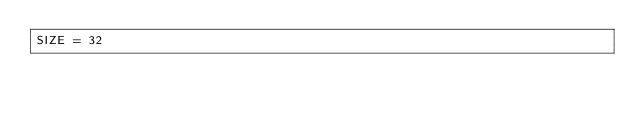<code> <loc_0><loc_0><loc_500><loc_500><_Python_>SIZE = 32
</code> 